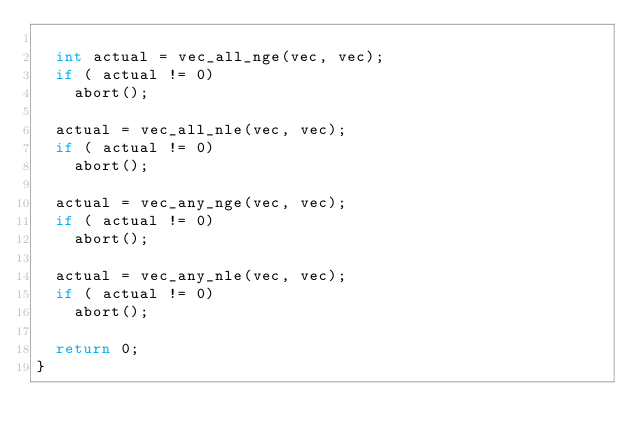<code> <loc_0><loc_0><loc_500><loc_500><_C_>
  int actual = vec_all_nge(vec, vec);
  if ( actual != 0)
    abort();

  actual = vec_all_nle(vec, vec);
  if ( actual != 0)
    abort();

  actual = vec_any_nge(vec, vec);
  if ( actual != 0)
    abort();

  actual = vec_any_nle(vec, vec);
  if ( actual != 0)
    abort();

  return 0;
}
</code> 